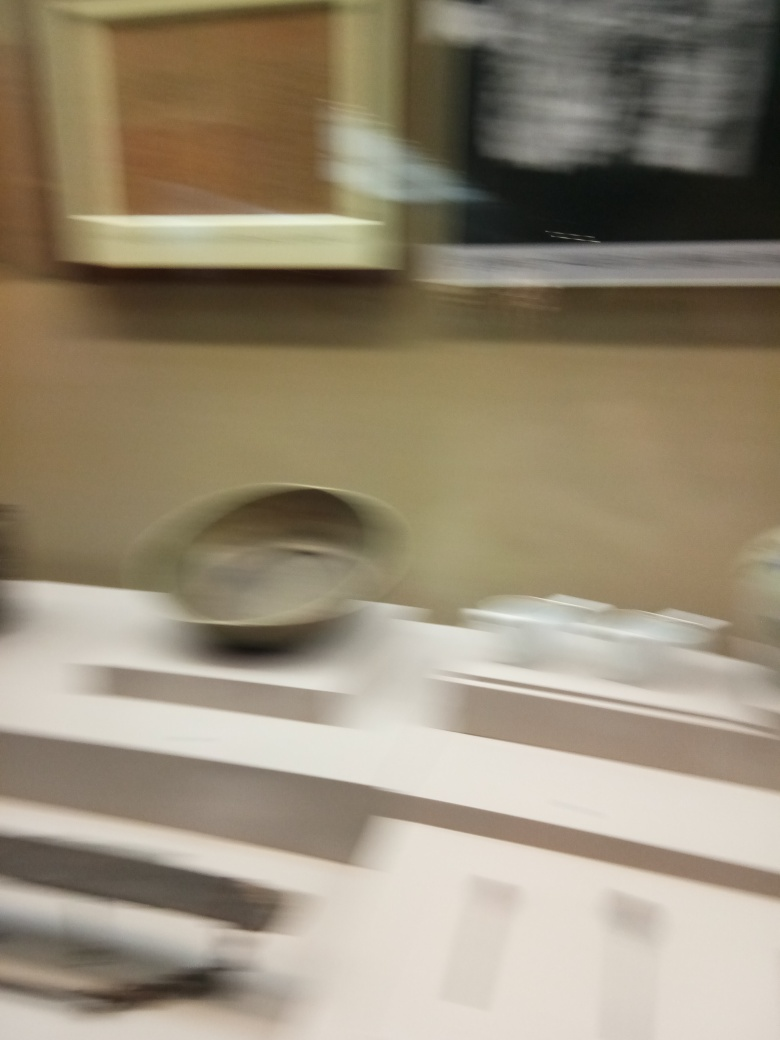What can this image potentially tell us about the setting and the moment when it was taken? Although the details are obscured by blur, the image seems to be taken indoors, possibly in a kitchen or dining area, as suggested by shapes resembling dishes and a counter. The sense of hurried movement can imply a dynamic scene, perhaps in a busy kitchen or during a quickly captured moment. 